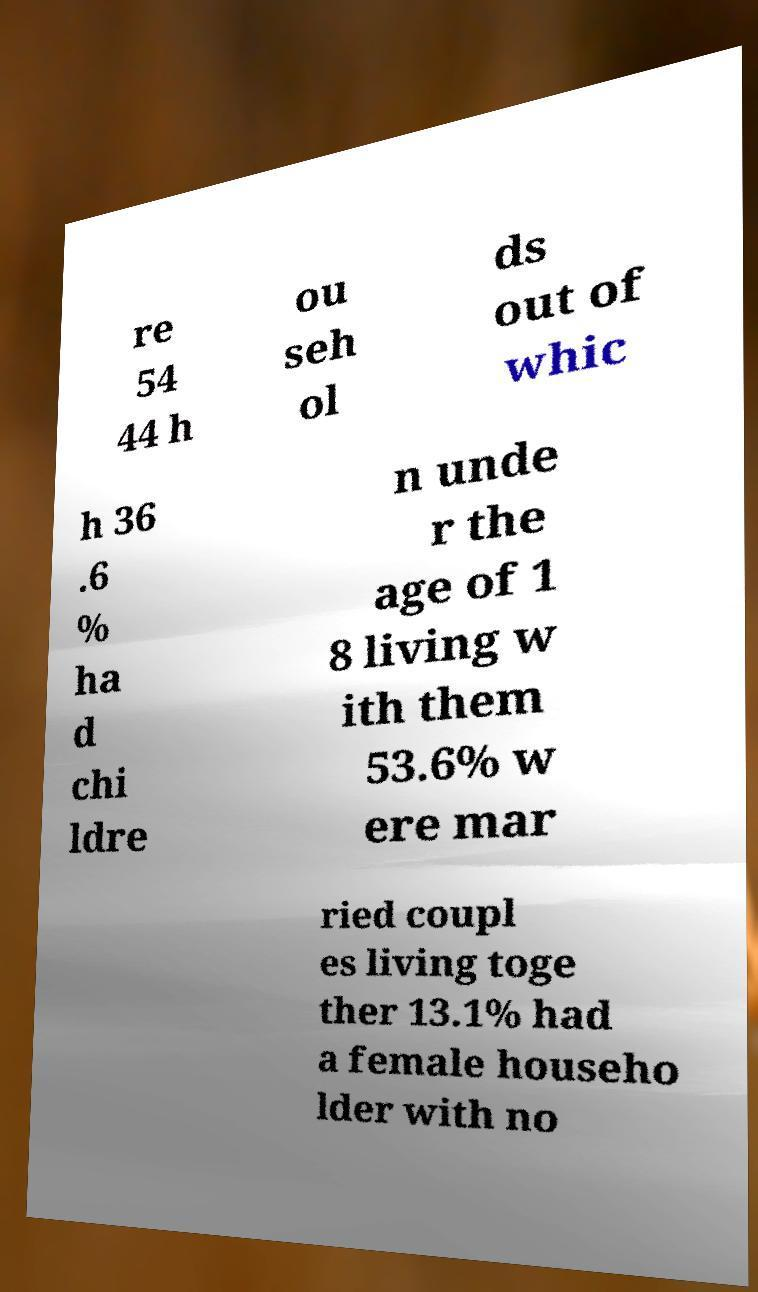Could you assist in decoding the text presented in this image and type it out clearly? re 54 44 h ou seh ol ds out of whic h 36 .6 % ha d chi ldre n unde r the age of 1 8 living w ith them 53.6% w ere mar ried coupl es living toge ther 13.1% had a female househo lder with no 